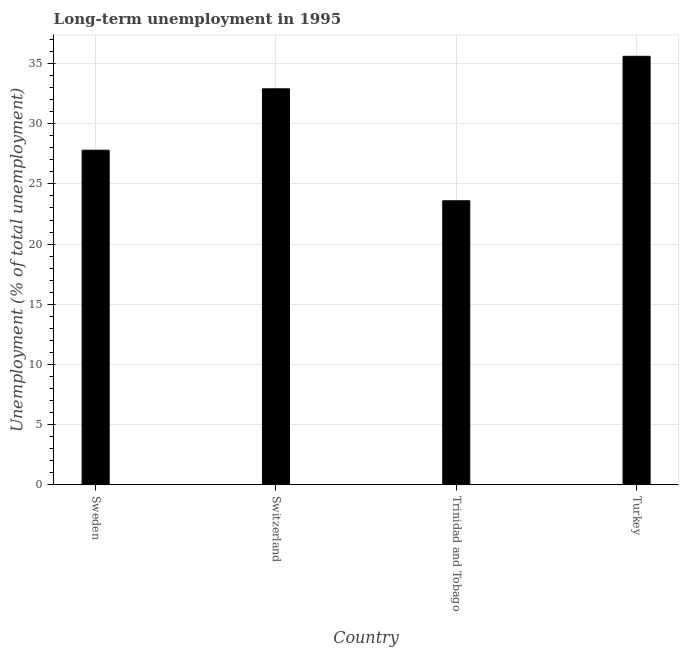Does the graph contain any zero values?
Offer a terse response. No. Does the graph contain grids?
Ensure brevity in your answer.  Yes. What is the title of the graph?
Offer a terse response. Long-term unemployment in 1995. What is the label or title of the Y-axis?
Your response must be concise. Unemployment (% of total unemployment). What is the long-term unemployment in Sweden?
Provide a short and direct response. 27.8. Across all countries, what is the maximum long-term unemployment?
Your answer should be very brief. 35.6. Across all countries, what is the minimum long-term unemployment?
Offer a terse response. 23.6. In which country was the long-term unemployment minimum?
Provide a succinct answer. Trinidad and Tobago. What is the sum of the long-term unemployment?
Offer a terse response. 119.9. What is the average long-term unemployment per country?
Offer a terse response. 29.98. What is the median long-term unemployment?
Your response must be concise. 30.35. What is the ratio of the long-term unemployment in Sweden to that in Turkey?
Make the answer very short. 0.78. What is the difference between the highest and the lowest long-term unemployment?
Offer a terse response. 12. How many countries are there in the graph?
Provide a succinct answer. 4. What is the Unemployment (% of total unemployment) of Sweden?
Provide a succinct answer. 27.8. What is the Unemployment (% of total unemployment) in Switzerland?
Offer a very short reply. 32.9. What is the Unemployment (% of total unemployment) in Trinidad and Tobago?
Offer a terse response. 23.6. What is the Unemployment (% of total unemployment) in Turkey?
Your answer should be very brief. 35.6. What is the difference between the Unemployment (% of total unemployment) in Sweden and Trinidad and Tobago?
Keep it short and to the point. 4.2. What is the difference between the Unemployment (% of total unemployment) in Switzerland and Turkey?
Provide a succinct answer. -2.7. What is the ratio of the Unemployment (% of total unemployment) in Sweden to that in Switzerland?
Give a very brief answer. 0.84. What is the ratio of the Unemployment (% of total unemployment) in Sweden to that in Trinidad and Tobago?
Offer a terse response. 1.18. What is the ratio of the Unemployment (% of total unemployment) in Sweden to that in Turkey?
Your answer should be compact. 0.78. What is the ratio of the Unemployment (% of total unemployment) in Switzerland to that in Trinidad and Tobago?
Keep it short and to the point. 1.39. What is the ratio of the Unemployment (% of total unemployment) in Switzerland to that in Turkey?
Provide a short and direct response. 0.92. What is the ratio of the Unemployment (% of total unemployment) in Trinidad and Tobago to that in Turkey?
Offer a very short reply. 0.66. 